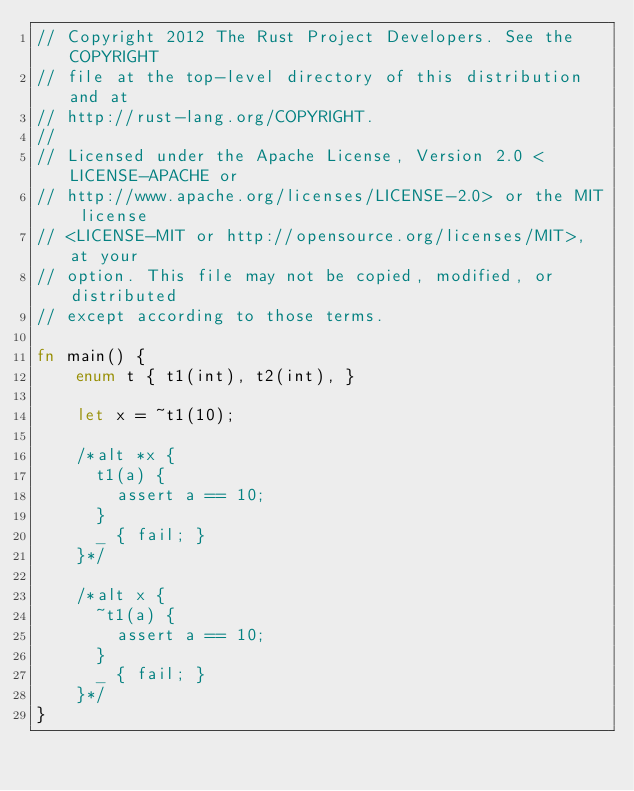Convert code to text. <code><loc_0><loc_0><loc_500><loc_500><_Rust_>// Copyright 2012 The Rust Project Developers. See the COPYRIGHT
// file at the top-level directory of this distribution and at
// http://rust-lang.org/COPYRIGHT.
//
// Licensed under the Apache License, Version 2.0 <LICENSE-APACHE or
// http://www.apache.org/licenses/LICENSE-2.0> or the MIT license
// <LICENSE-MIT or http://opensource.org/licenses/MIT>, at your
// option. This file may not be copied, modified, or distributed
// except according to those terms.

fn main() {
    enum t { t1(int), t2(int), }

    let x = ~t1(10);

    /*alt *x {
      t1(a) {
        assert a == 10;
      }
      _ { fail; }
    }*/

    /*alt x {
      ~t1(a) {
        assert a == 10;
      }
      _ { fail; }
    }*/
}</code> 